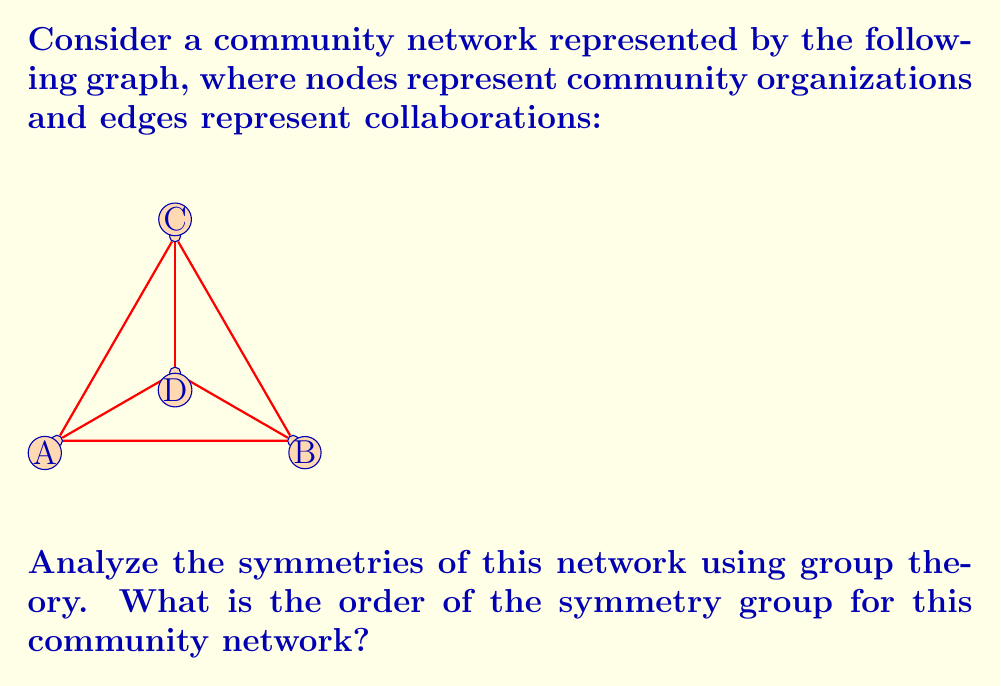What is the answer to this math problem? To analyze the symmetries of this community network, we'll follow these steps:

1) First, we need to identify all possible symmetries of the graph. A symmetry is a transformation that preserves the structure of the graph.

2) In this case, we have a tetrahedron-like structure with one internal node (D). The symmetries will be rotations and reflections that keep the overall structure intact.

3) Let's list all the symmetries:
   - Identity (do nothing)
   - 120° rotation around the axis through C and the center of triangle ABD (2 rotations possible: clockwise and counterclockwise)
   - 180° rotation around the axis through D and the midpoint of AC
   - 180° rotation around the axis through D and the midpoint of BC
   - 180° rotation around the axis through D and the midpoint of AB
   - Reflection across the plane containing C and the midpoint of AB
   - Reflection across the plane containing A and the midpoint of BC
   - Reflection across the plane containing B and the midpoint of AC

4) Count the total number of symmetries:
   1 (identity) + 2 (120° rotations) + 3 (180° rotations) + 3 (reflections) = 9

5) In group theory, the collection of these symmetries forms a group under composition. The order of a group is the number of elements in the group.

Therefore, the order of the symmetry group for this community network is 9.

This group is isomorphic to the dihedral group $D_3$, which is the symmetry group of an equilateral triangle. This reflects the underlying triangular structure of the network when viewed from above.
Answer: 9 